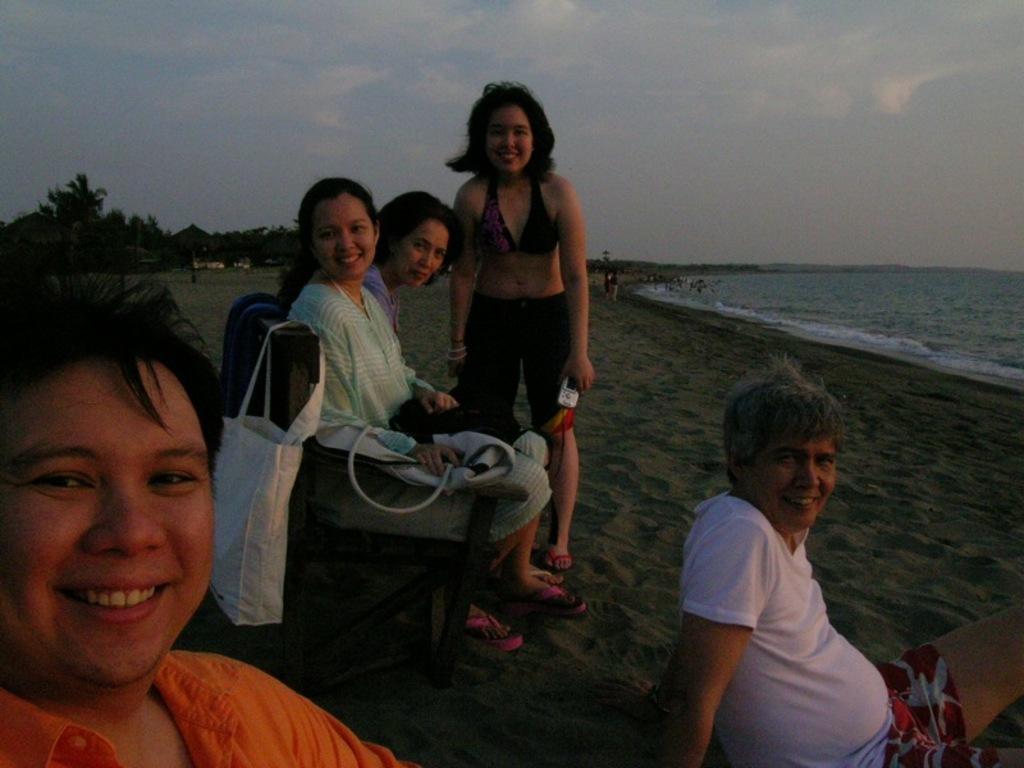Can you describe this image briefly? In this picture I can see people among them a woman is standing and rest of the people are sitting. These people are smiling. In the background I can see the sky, people and trees. On the right side I can see water. 